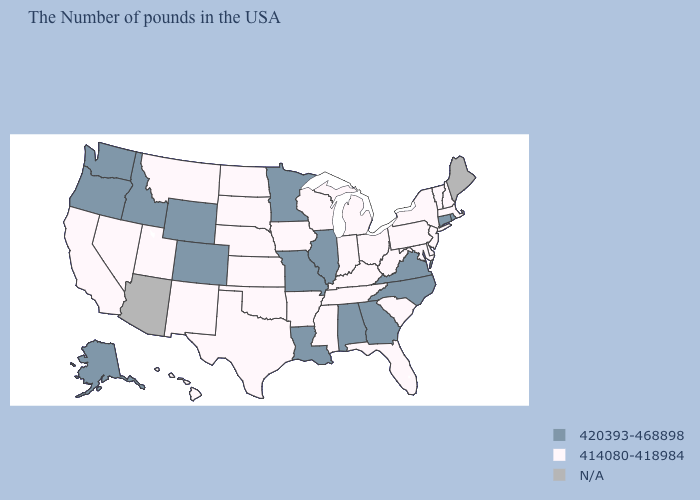Does New Hampshire have the lowest value in the Northeast?
Short answer required. Yes. Name the states that have a value in the range 420393-468898?
Keep it brief. Rhode Island, Connecticut, Virginia, North Carolina, Georgia, Alabama, Illinois, Louisiana, Missouri, Minnesota, Wyoming, Colorado, Idaho, Washington, Oregon, Alaska. What is the highest value in the USA?
Write a very short answer. 420393-468898. Name the states that have a value in the range N/A?
Keep it brief. Maine, Arizona. What is the highest value in the USA?
Be succinct. 420393-468898. Name the states that have a value in the range 414080-418984?
Answer briefly. Massachusetts, New Hampshire, Vermont, New York, New Jersey, Delaware, Maryland, Pennsylvania, South Carolina, West Virginia, Ohio, Florida, Michigan, Kentucky, Indiana, Tennessee, Wisconsin, Mississippi, Arkansas, Iowa, Kansas, Nebraska, Oklahoma, Texas, South Dakota, North Dakota, New Mexico, Utah, Montana, Nevada, California, Hawaii. What is the highest value in the USA?
Keep it brief. 420393-468898. What is the value of New York?
Quick response, please. 414080-418984. Does the first symbol in the legend represent the smallest category?
Answer briefly. No. What is the lowest value in the South?
Answer briefly. 414080-418984. Among the states that border Kentucky , which have the highest value?
Answer briefly. Virginia, Illinois, Missouri. What is the value of New Mexico?
Short answer required. 414080-418984. Which states have the lowest value in the Northeast?
Short answer required. Massachusetts, New Hampshire, Vermont, New York, New Jersey, Pennsylvania. 